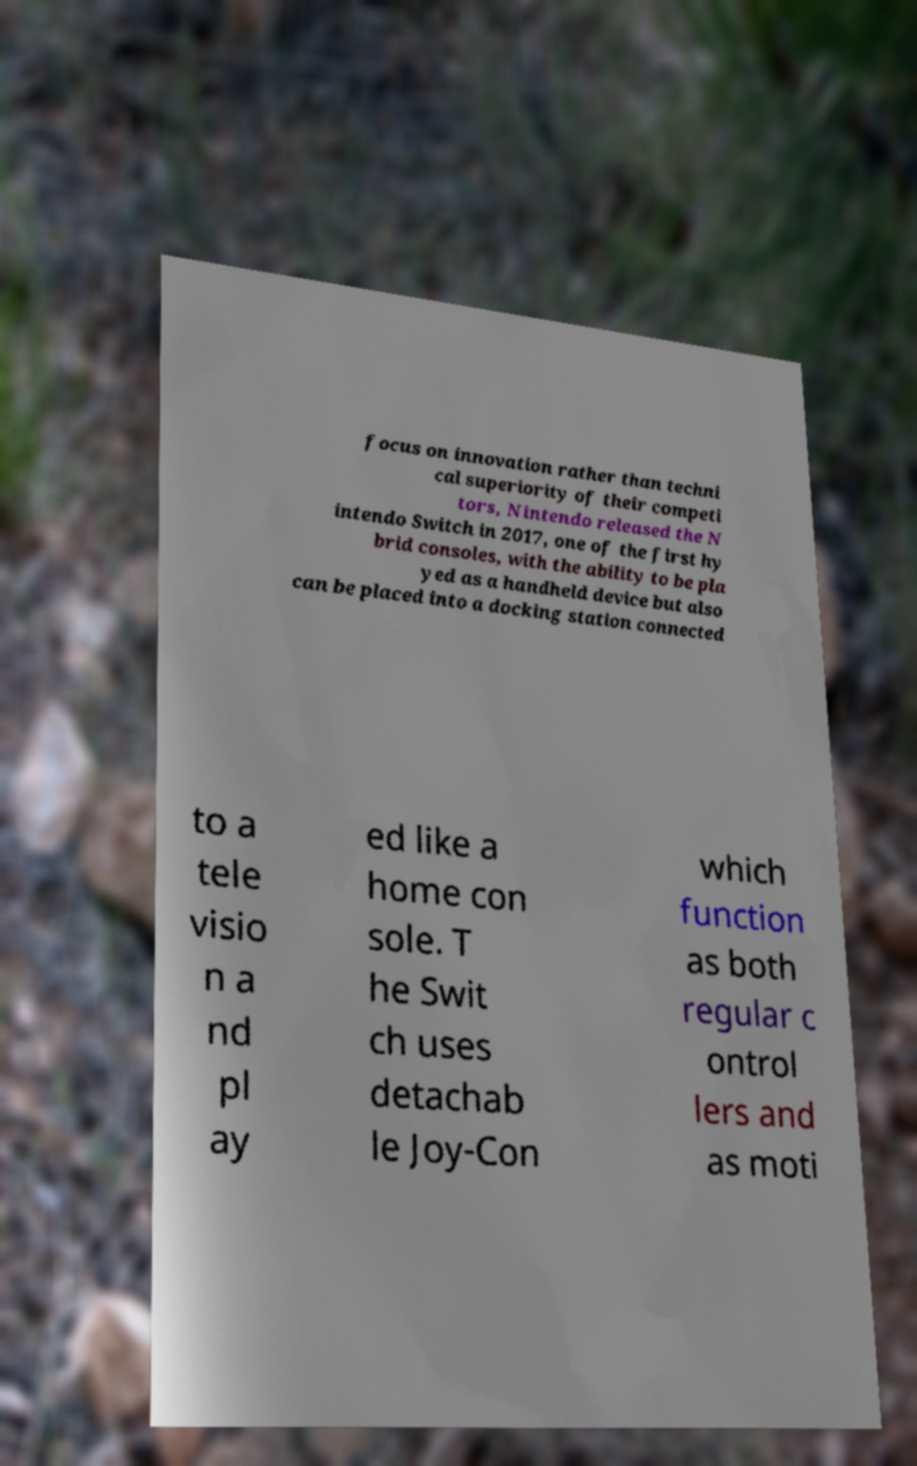I need the written content from this picture converted into text. Can you do that? focus on innovation rather than techni cal superiority of their competi tors, Nintendo released the N intendo Switch in 2017, one of the first hy brid consoles, with the ability to be pla yed as a handheld device but also can be placed into a docking station connected to a tele visio n a nd pl ay ed like a home con sole. T he Swit ch uses detachab le Joy-Con which function as both regular c ontrol lers and as moti 